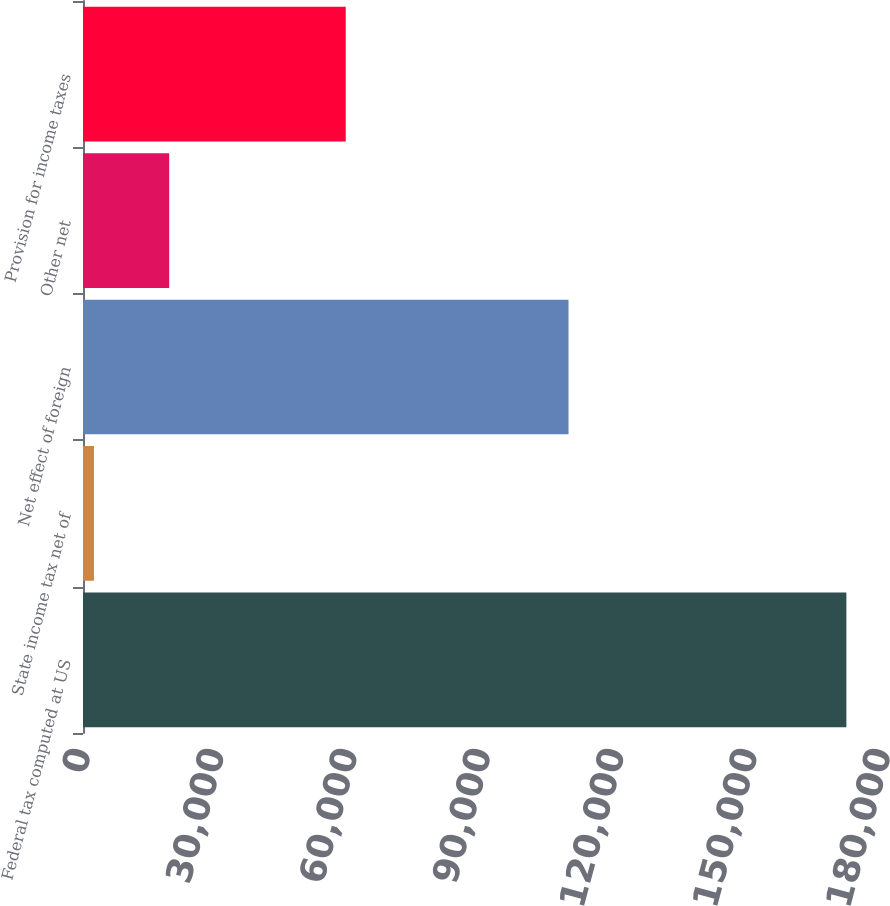Convert chart to OTSL. <chart><loc_0><loc_0><loc_500><loc_500><bar_chart><fcel>Federal tax computed at US<fcel>State income tax net of<fcel>Net effect of foreign<fcel>Other net<fcel>Provision for income taxes<nl><fcel>171759<fcel>2464<fcel>109240<fcel>19393.5<fcel>59120<nl></chart> 